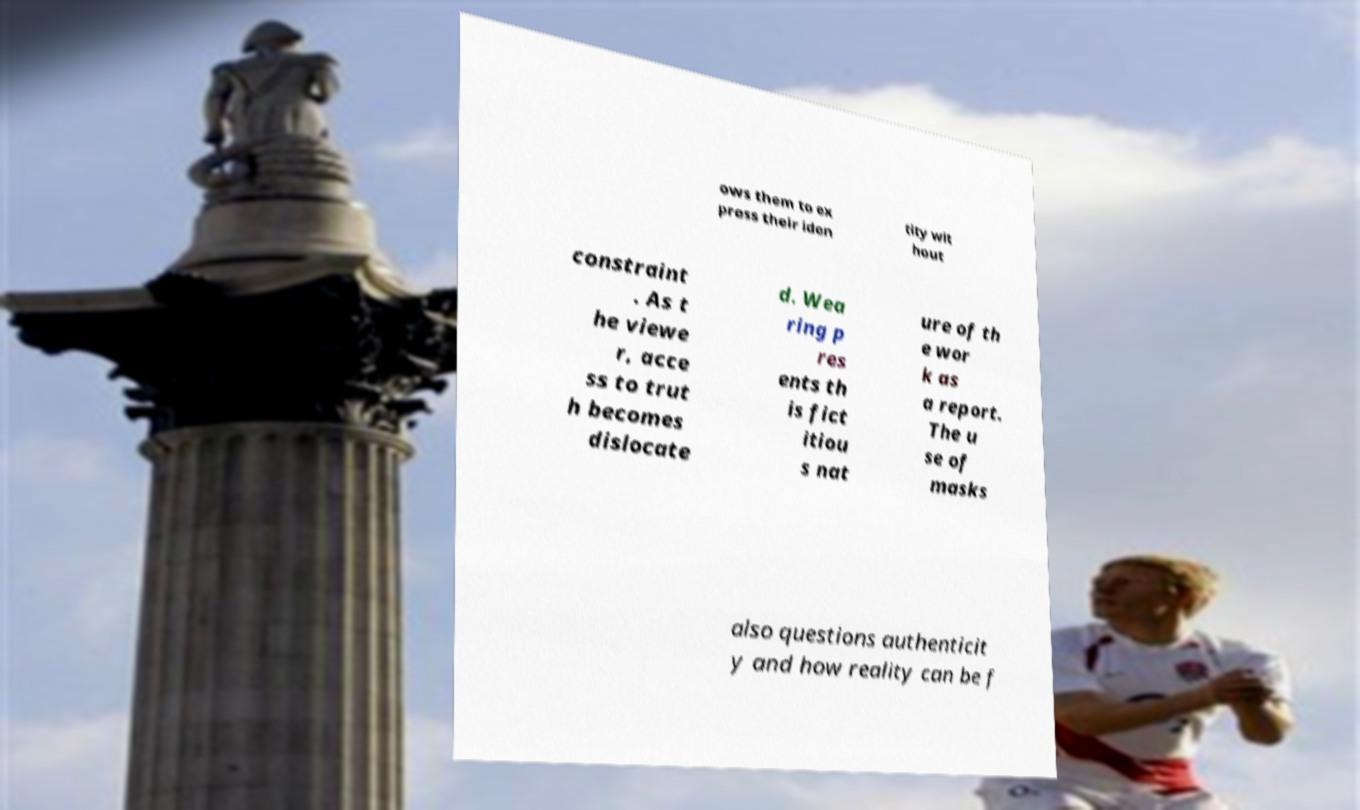Can you read and provide the text displayed in the image?This photo seems to have some interesting text. Can you extract and type it out for me? ows them to ex press their iden tity wit hout constraint . As t he viewe r, acce ss to trut h becomes dislocate d. Wea ring p res ents th is fict itiou s nat ure of th e wor k as a report. The u se of masks also questions authenticit y and how reality can be f 